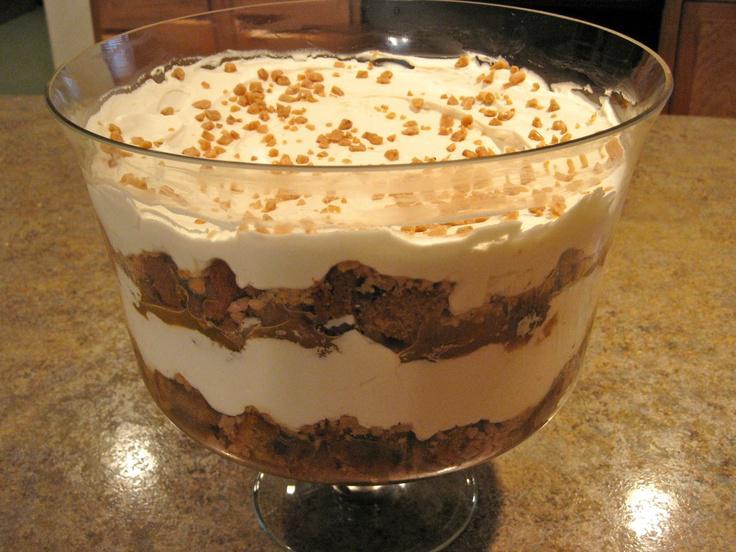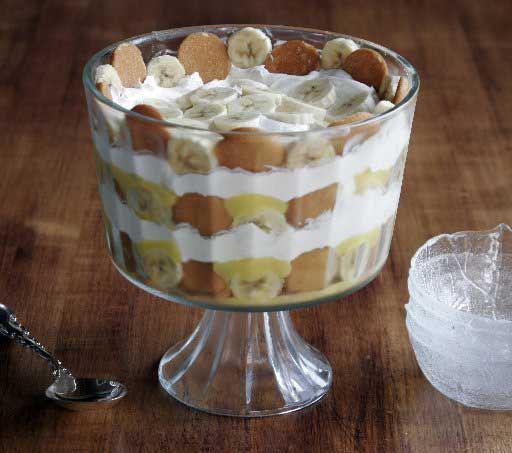The first image is the image on the left, the second image is the image on the right. Assess this claim about the two images: "There is one layered dessert in each image, and they are both in dishes with stems.". Correct or not? Answer yes or no. Yes. 